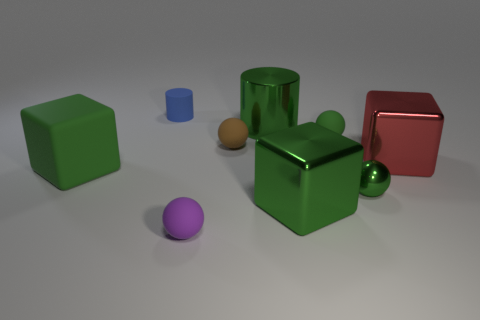Subtract all gray balls. Subtract all cyan blocks. How many balls are left? 4 Subtract all balls. How many objects are left? 5 Subtract 1 brown balls. How many objects are left? 8 Subtract all large green matte cubes. Subtract all purple matte things. How many objects are left? 7 Add 7 shiny cylinders. How many shiny cylinders are left? 8 Add 3 tiny shiny things. How many tiny shiny things exist? 4 